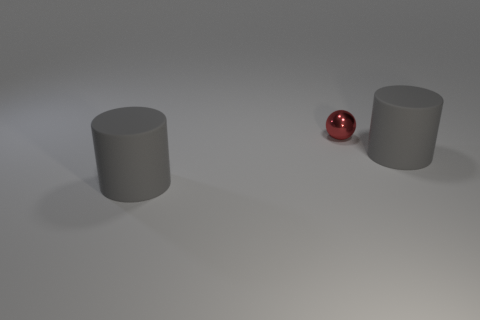Add 1 gray rubber objects. How many objects exist? 4 Subtract all spheres. How many objects are left? 2 Subtract 0 purple balls. How many objects are left? 3 Subtract all tiny red balls. Subtract all shiny spheres. How many objects are left? 1 Add 2 red metallic spheres. How many red metallic spheres are left? 3 Add 1 large rubber objects. How many large rubber objects exist? 3 